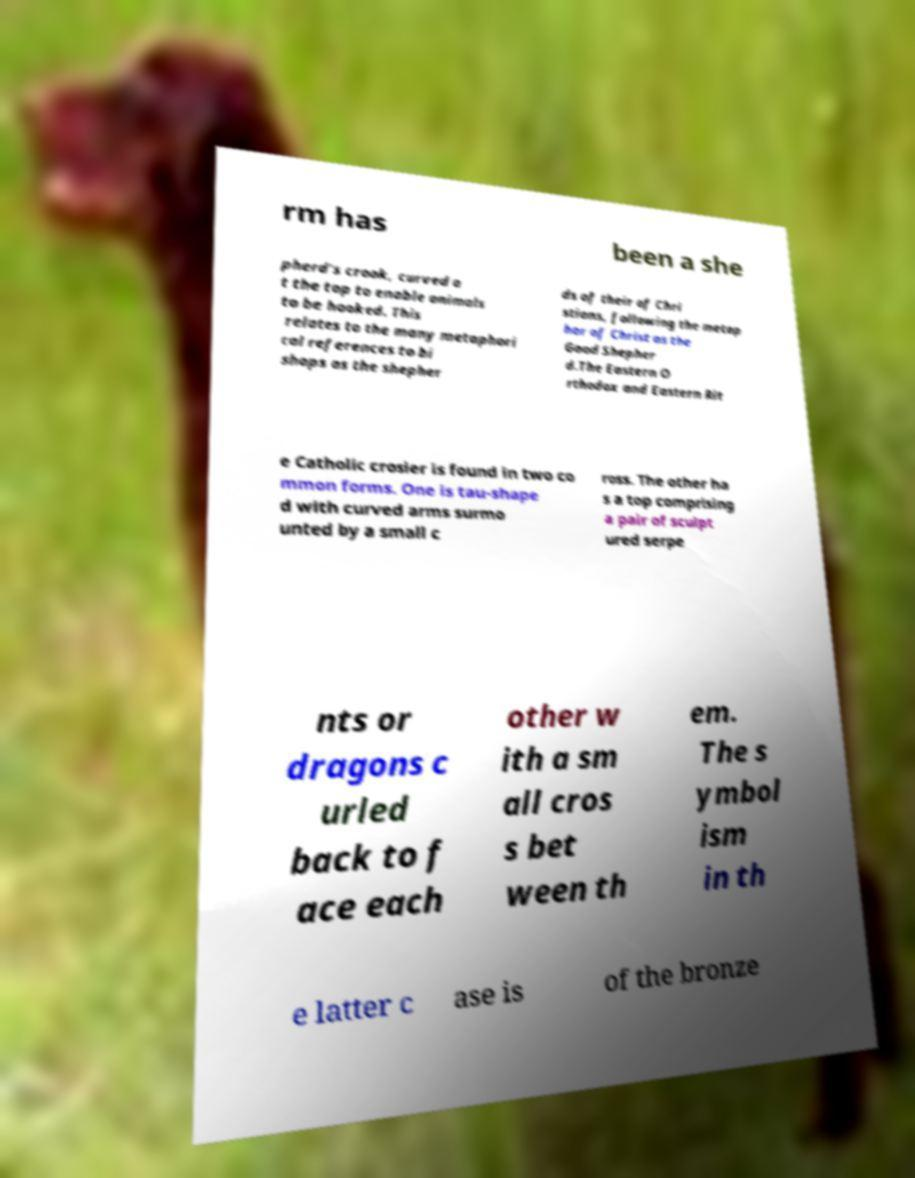Could you extract and type out the text from this image? rm has been a she pherd's crook, curved a t the top to enable animals to be hooked. This relates to the many metaphori cal references to bi shops as the shepher ds of their of Chri stians, following the metap hor of Christ as the Good Shepher d.The Eastern O rthodox and Eastern Rit e Catholic crosier is found in two co mmon forms. One is tau-shape d with curved arms surmo unted by a small c ross. The other ha s a top comprising a pair of sculpt ured serpe nts or dragons c urled back to f ace each other w ith a sm all cros s bet ween th em. The s ymbol ism in th e latter c ase is of the bronze 